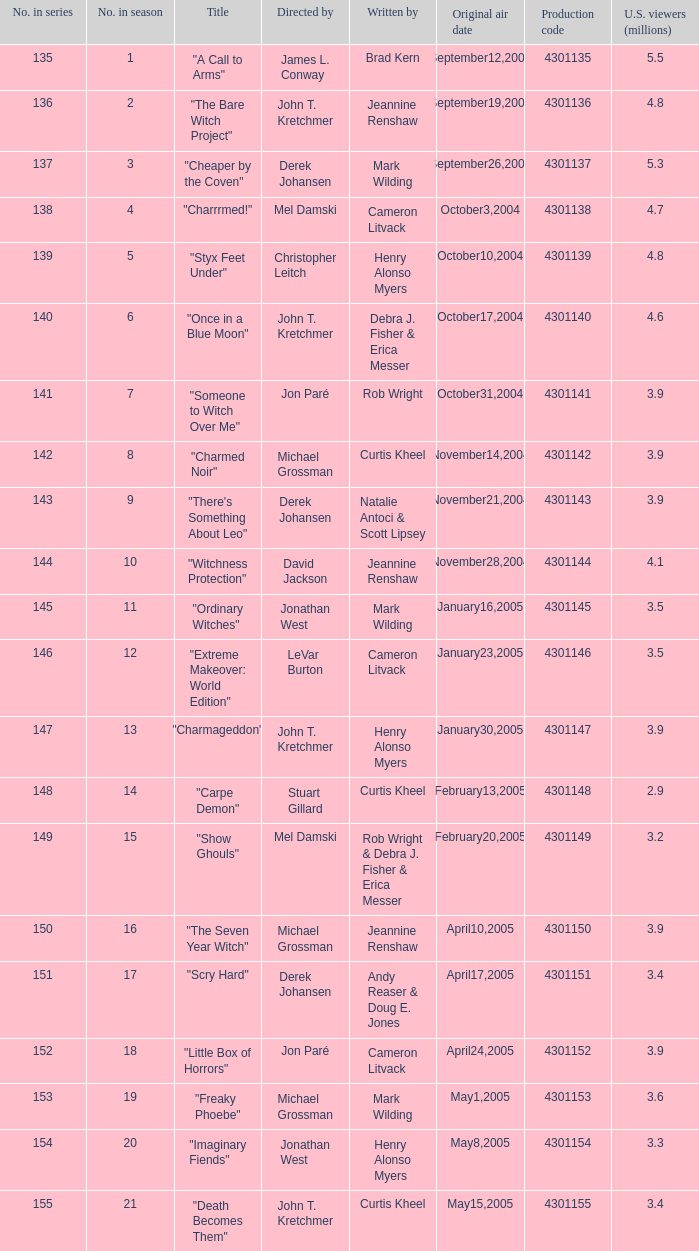In season three, who were the creators? Mark Wilding. 